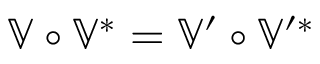Convert formula to latex. <formula><loc_0><loc_0><loc_500><loc_500>\mathbb { V } \circ \mathbb { V } ^ { \ast } = \mathbb { V } ^ { \prime } \circ \mathbb { V } ^ { \prime \ast }</formula> 